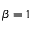Convert formula to latex. <formula><loc_0><loc_0><loc_500><loc_500>\beta = 1</formula> 